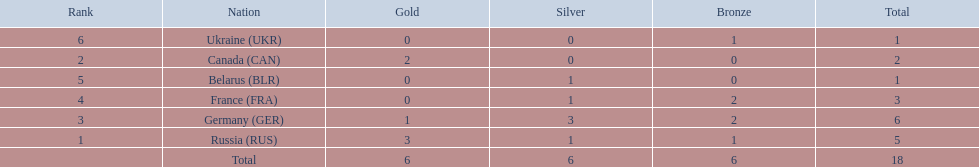Which countries received gold medals? Russia (RUS), Canada (CAN), Germany (GER). Of these countries, which did not receive a silver medal? Canada (CAN). 